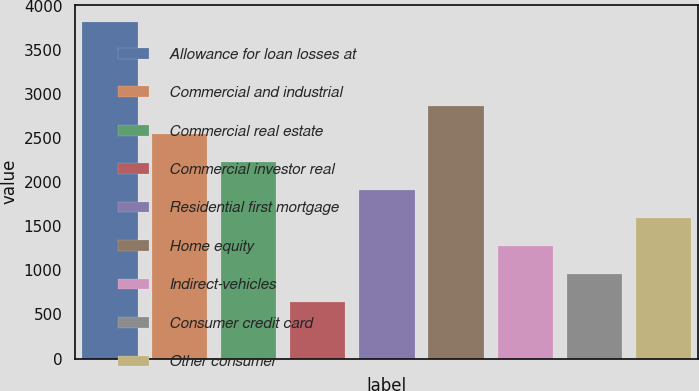Convert chart to OTSL. <chart><loc_0><loc_0><loc_500><loc_500><bar_chart><fcel>Allowance for loan losses at<fcel>Commercial and industrial<fcel>Commercial real estate<fcel>Commercial investor real<fcel>Residential first mortgage<fcel>Home equity<fcel>Indirect-vehicles<fcel>Consumer credit card<fcel>Other consumer<nl><fcel>3821.56<fcel>2548.52<fcel>2230.26<fcel>638.96<fcel>1912<fcel>2866.78<fcel>1275.48<fcel>957.22<fcel>1593.74<nl></chart> 